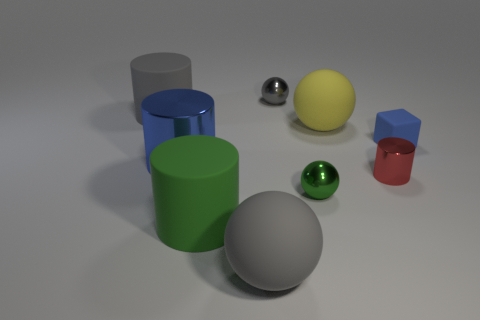Are there any other things that have the same size as the blue cube?
Provide a short and direct response. Yes. Does the yellow rubber thing have the same shape as the blue rubber thing?
Offer a very short reply. No. There is a blue object right of the big matte cylinder that is in front of the gray cylinder; what size is it?
Your answer should be very brief. Small. There is a small shiny thing that is the same shape as the large green matte thing; what is its color?
Your response must be concise. Red. What number of big spheres are the same color as the tiny rubber thing?
Provide a succinct answer. 0. What size is the matte cube?
Your answer should be compact. Small. Do the blue block and the red metallic cylinder have the same size?
Provide a short and direct response. Yes. There is a big object that is both right of the green matte thing and behind the big green object; what color is it?
Make the answer very short. Yellow. What number of yellow cubes are made of the same material as the red object?
Provide a succinct answer. 0. How many small red shiny cylinders are there?
Offer a terse response. 1. 